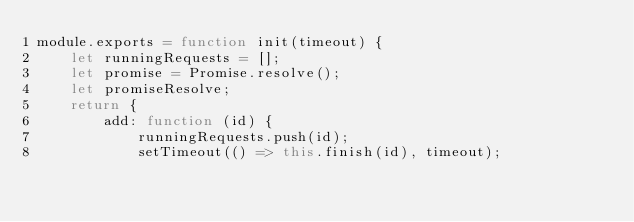Convert code to text. <code><loc_0><loc_0><loc_500><loc_500><_JavaScript_>module.exports = function init(timeout) {
    let runningRequests = [];
    let promise = Promise.resolve();
    let promiseResolve;
    return {
        add: function (id) {
            runningRequests.push(id);
            setTimeout(() => this.finish(id), timeout);</code> 